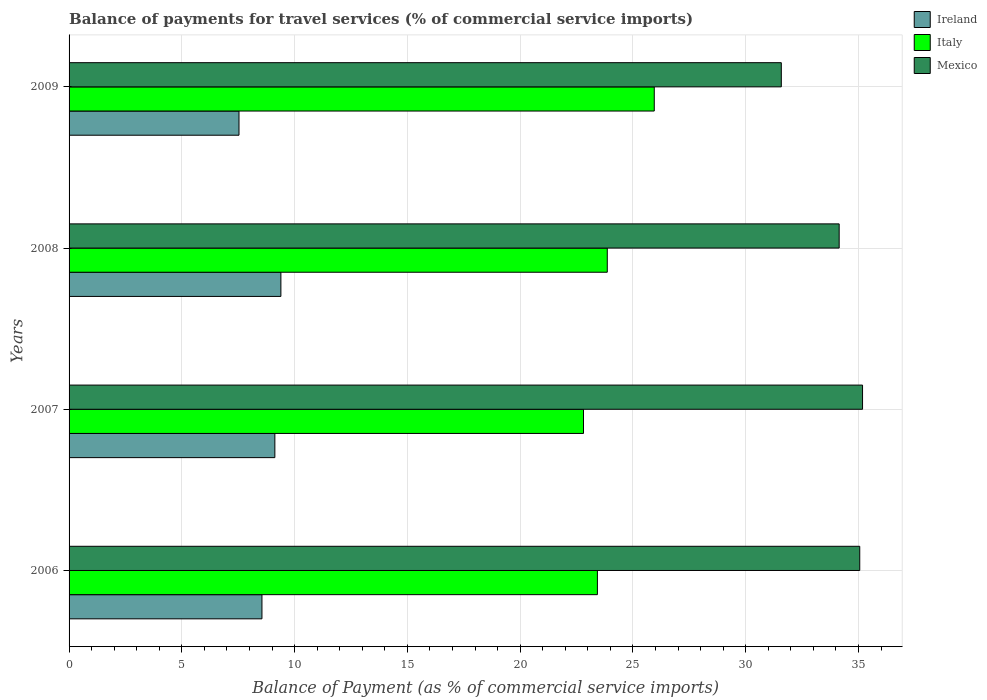How many different coloured bars are there?
Make the answer very short. 3. How many groups of bars are there?
Offer a very short reply. 4. How many bars are there on the 4th tick from the top?
Provide a succinct answer. 3. How many bars are there on the 4th tick from the bottom?
Provide a succinct answer. 3. What is the label of the 3rd group of bars from the top?
Offer a terse response. 2007. What is the balance of payments for travel services in Ireland in 2006?
Your response must be concise. 8.55. Across all years, what is the maximum balance of payments for travel services in Italy?
Make the answer very short. 25.95. Across all years, what is the minimum balance of payments for travel services in Ireland?
Offer a terse response. 7.53. In which year was the balance of payments for travel services in Italy maximum?
Offer a terse response. 2009. What is the total balance of payments for travel services in Ireland in the graph?
Your answer should be very brief. 34.6. What is the difference between the balance of payments for travel services in Ireland in 2006 and that in 2008?
Your response must be concise. -0.84. What is the difference between the balance of payments for travel services in Italy in 2006 and the balance of payments for travel services in Ireland in 2009?
Keep it short and to the point. 15.89. What is the average balance of payments for travel services in Mexico per year?
Offer a very short reply. 33.99. In the year 2009, what is the difference between the balance of payments for travel services in Italy and balance of payments for travel services in Ireland?
Your answer should be very brief. 18.41. What is the ratio of the balance of payments for travel services in Mexico in 2006 to that in 2007?
Ensure brevity in your answer.  1. What is the difference between the highest and the second highest balance of payments for travel services in Ireland?
Provide a short and direct response. 0.27. What is the difference between the highest and the lowest balance of payments for travel services in Italy?
Your answer should be very brief. 3.14. Is the sum of the balance of payments for travel services in Mexico in 2006 and 2009 greater than the maximum balance of payments for travel services in Italy across all years?
Your answer should be very brief. Yes. What does the 1st bar from the bottom in 2009 represents?
Your response must be concise. Ireland. Is it the case that in every year, the sum of the balance of payments for travel services in Italy and balance of payments for travel services in Ireland is greater than the balance of payments for travel services in Mexico?
Provide a succinct answer. No. Are all the bars in the graph horizontal?
Provide a succinct answer. Yes. Does the graph contain grids?
Your answer should be compact. Yes. Where does the legend appear in the graph?
Keep it short and to the point. Top right. How many legend labels are there?
Your response must be concise. 3. What is the title of the graph?
Provide a succinct answer. Balance of payments for travel services (% of commercial service imports). Does "Europe(all income levels)" appear as one of the legend labels in the graph?
Provide a short and direct response. No. What is the label or title of the X-axis?
Ensure brevity in your answer.  Balance of Payment (as % of commercial service imports). What is the label or title of the Y-axis?
Your answer should be very brief. Years. What is the Balance of Payment (as % of commercial service imports) in Ireland in 2006?
Offer a very short reply. 8.55. What is the Balance of Payment (as % of commercial service imports) in Italy in 2006?
Make the answer very short. 23.43. What is the Balance of Payment (as % of commercial service imports) in Mexico in 2006?
Make the answer very short. 35.06. What is the Balance of Payment (as % of commercial service imports) in Ireland in 2007?
Your answer should be very brief. 9.12. What is the Balance of Payment (as % of commercial service imports) in Italy in 2007?
Your response must be concise. 22.81. What is the Balance of Payment (as % of commercial service imports) in Mexico in 2007?
Make the answer very short. 35.18. What is the Balance of Payment (as % of commercial service imports) in Ireland in 2008?
Provide a succinct answer. 9.39. What is the Balance of Payment (as % of commercial service imports) of Italy in 2008?
Make the answer very short. 23.86. What is the Balance of Payment (as % of commercial service imports) of Mexico in 2008?
Keep it short and to the point. 34.14. What is the Balance of Payment (as % of commercial service imports) in Ireland in 2009?
Keep it short and to the point. 7.53. What is the Balance of Payment (as % of commercial service imports) of Italy in 2009?
Your answer should be very brief. 25.95. What is the Balance of Payment (as % of commercial service imports) of Mexico in 2009?
Your response must be concise. 31.58. Across all years, what is the maximum Balance of Payment (as % of commercial service imports) in Ireland?
Your response must be concise. 9.39. Across all years, what is the maximum Balance of Payment (as % of commercial service imports) in Italy?
Make the answer very short. 25.95. Across all years, what is the maximum Balance of Payment (as % of commercial service imports) of Mexico?
Provide a succinct answer. 35.18. Across all years, what is the minimum Balance of Payment (as % of commercial service imports) in Ireland?
Offer a terse response. 7.53. Across all years, what is the minimum Balance of Payment (as % of commercial service imports) in Italy?
Ensure brevity in your answer.  22.81. Across all years, what is the minimum Balance of Payment (as % of commercial service imports) of Mexico?
Ensure brevity in your answer.  31.58. What is the total Balance of Payment (as % of commercial service imports) in Ireland in the graph?
Offer a terse response. 34.6. What is the total Balance of Payment (as % of commercial service imports) of Italy in the graph?
Ensure brevity in your answer.  96.04. What is the total Balance of Payment (as % of commercial service imports) of Mexico in the graph?
Make the answer very short. 135.96. What is the difference between the Balance of Payment (as % of commercial service imports) of Ireland in 2006 and that in 2007?
Offer a terse response. -0.57. What is the difference between the Balance of Payment (as % of commercial service imports) of Italy in 2006 and that in 2007?
Offer a terse response. 0.62. What is the difference between the Balance of Payment (as % of commercial service imports) in Mexico in 2006 and that in 2007?
Your answer should be very brief. -0.12. What is the difference between the Balance of Payment (as % of commercial service imports) in Ireland in 2006 and that in 2008?
Provide a succinct answer. -0.84. What is the difference between the Balance of Payment (as % of commercial service imports) in Italy in 2006 and that in 2008?
Your answer should be very brief. -0.44. What is the difference between the Balance of Payment (as % of commercial service imports) of Mexico in 2006 and that in 2008?
Ensure brevity in your answer.  0.91. What is the difference between the Balance of Payment (as % of commercial service imports) of Ireland in 2006 and that in 2009?
Ensure brevity in your answer.  1.02. What is the difference between the Balance of Payment (as % of commercial service imports) of Italy in 2006 and that in 2009?
Offer a terse response. -2.52. What is the difference between the Balance of Payment (as % of commercial service imports) of Mexico in 2006 and that in 2009?
Make the answer very short. 3.48. What is the difference between the Balance of Payment (as % of commercial service imports) in Ireland in 2007 and that in 2008?
Provide a short and direct response. -0.27. What is the difference between the Balance of Payment (as % of commercial service imports) of Italy in 2007 and that in 2008?
Provide a short and direct response. -1.05. What is the difference between the Balance of Payment (as % of commercial service imports) of Mexico in 2007 and that in 2008?
Provide a short and direct response. 1.04. What is the difference between the Balance of Payment (as % of commercial service imports) of Ireland in 2007 and that in 2009?
Keep it short and to the point. 1.59. What is the difference between the Balance of Payment (as % of commercial service imports) in Italy in 2007 and that in 2009?
Make the answer very short. -3.14. What is the difference between the Balance of Payment (as % of commercial service imports) in Mexico in 2007 and that in 2009?
Offer a terse response. 3.6. What is the difference between the Balance of Payment (as % of commercial service imports) of Ireland in 2008 and that in 2009?
Provide a short and direct response. 1.86. What is the difference between the Balance of Payment (as % of commercial service imports) in Italy in 2008 and that in 2009?
Make the answer very short. -2.08. What is the difference between the Balance of Payment (as % of commercial service imports) of Mexico in 2008 and that in 2009?
Provide a short and direct response. 2.56. What is the difference between the Balance of Payment (as % of commercial service imports) of Ireland in 2006 and the Balance of Payment (as % of commercial service imports) of Italy in 2007?
Provide a succinct answer. -14.26. What is the difference between the Balance of Payment (as % of commercial service imports) of Ireland in 2006 and the Balance of Payment (as % of commercial service imports) of Mexico in 2007?
Keep it short and to the point. -26.63. What is the difference between the Balance of Payment (as % of commercial service imports) in Italy in 2006 and the Balance of Payment (as % of commercial service imports) in Mexico in 2007?
Give a very brief answer. -11.76. What is the difference between the Balance of Payment (as % of commercial service imports) of Ireland in 2006 and the Balance of Payment (as % of commercial service imports) of Italy in 2008?
Your answer should be compact. -15.31. What is the difference between the Balance of Payment (as % of commercial service imports) in Ireland in 2006 and the Balance of Payment (as % of commercial service imports) in Mexico in 2008?
Provide a succinct answer. -25.59. What is the difference between the Balance of Payment (as % of commercial service imports) in Italy in 2006 and the Balance of Payment (as % of commercial service imports) in Mexico in 2008?
Make the answer very short. -10.72. What is the difference between the Balance of Payment (as % of commercial service imports) of Ireland in 2006 and the Balance of Payment (as % of commercial service imports) of Italy in 2009?
Give a very brief answer. -17.39. What is the difference between the Balance of Payment (as % of commercial service imports) in Ireland in 2006 and the Balance of Payment (as % of commercial service imports) in Mexico in 2009?
Provide a short and direct response. -23.03. What is the difference between the Balance of Payment (as % of commercial service imports) in Italy in 2006 and the Balance of Payment (as % of commercial service imports) in Mexico in 2009?
Give a very brief answer. -8.15. What is the difference between the Balance of Payment (as % of commercial service imports) in Ireland in 2007 and the Balance of Payment (as % of commercial service imports) in Italy in 2008?
Make the answer very short. -14.74. What is the difference between the Balance of Payment (as % of commercial service imports) in Ireland in 2007 and the Balance of Payment (as % of commercial service imports) in Mexico in 2008?
Your answer should be compact. -25.02. What is the difference between the Balance of Payment (as % of commercial service imports) of Italy in 2007 and the Balance of Payment (as % of commercial service imports) of Mexico in 2008?
Your response must be concise. -11.34. What is the difference between the Balance of Payment (as % of commercial service imports) in Ireland in 2007 and the Balance of Payment (as % of commercial service imports) in Italy in 2009?
Give a very brief answer. -16.82. What is the difference between the Balance of Payment (as % of commercial service imports) of Ireland in 2007 and the Balance of Payment (as % of commercial service imports) of Mexico in 2009?
Provide a short and direct response. -22.46. What is the difference between the Balance of Payment (as % of commercial service imports) in Italy in 2007 and the Balance of Payment (as % of commercial service imports) in Mexico in 2009?
Provide a short and direct response. -8.77. What is the difference between the Balance of Payment (as % of commercial service imports) in Ireland in 2008 and the Balance of Payment (as % of commercial service imports) in Italy in 2009?
Provide a short and direct response. -16.55. What is the difference between the Balance of Payment (as % of commercial service imports) of Ireland in 2008 and the Balance of Payment (as % of commercial service imports) of Mexico in 2009?
Your answer should be very brief. -22.19. What is the difference between the Balance of Payment (as % of commercial service imports) of Italy in 2008 and the Balance of Payment (as % of commercial service imports) of Mexico in 2009?
Your answer should be compact. -7.72. What is the average Balance of Payment (as % of commercial service imports) of Ireland per year?
Make the answer very short. 8.65. What is the average Balance of Payment (as % of commercial service imports) of Italy per year?
Your response must be concise. 24.01. What is the average Balance of Payment (as % of commercial service imports) in Mexico per year?
Make the answer very short. 33.99. In the year 2006, what is the difference between the Balance of Payment (as % of commercial service imports) of Ireland and Balance of Payment (as % of commercial service imports) of Italy?
Ensure brevity in your answer.  -14.87. In the year 2006, what is the difference between the Balance of Payment (as % of commercial service imports) of Ireland and Balance of Payment (as % of commercial service imports) of Mexico?
Provide a short and direct response. -26.51. In the year 2006, what is the difference between the Balance of Payment (as % of commercial service imports) of Italy and Balance of Payment (as % of commercial service imports) of Mexico?
Your answer should be very brief. -11.63. In the year 2007, what is the difference between the Balance of Payment (as % of commercial service imports) of Ireland and Balance of Payment (as % of commercial service imports) of Italy?
Provide a short and direct response. -13.68. In the year 2007, what is the difference between the Balance of Payment (as % of commercial service imports) of Ireland and Balance of Payment (as % of commercial service imports) of Mexico?
Your response must be concise. -26.06. In the year 2007, what is the difference between the Balance of Payment (as % of commercial service imports) of Italy and Balance of Payment (as % of commercial service imports) of Mexico?
Make the answer very short. -12.37. In the year 2008, what is the difference between the Balance of Payment (as % of commercial service imports) in Ireland and Balance of Payment (as % of commercial service imports) in Italy?
Your answer should be compact. -14.47. In the year 2008, what is the difference between the Balance of Payment (as % of commercial service imports) in Ireland and Balance of Payment (as % of commercial service imports) in Mexico?
Keep it short and to the point. -24.75. In the year 2008, what is the difference between the Balance of Payment (as % of commercial service imports) of Italy and Balance of Payment (as % of commercial service imports) of Mexico?
Your answer should be very brief. -10.28. In the year 2009, what is the difference between the Balance of Payment (as % of commercial service imports) of Ireland and Balance of Payment (as % of commercial service imports) of Italy?
Provide a succinct answer. -18.41. In the year 2009, what is the difference between the Balance of Payment (as % of commercial service imports) of Ireland and Balance of Payment (as % of commercial service imports) of Mexico?
Give a very brief answer. -24.05. In the year 2009, what is the difference between the Balance of Payment (as % of commercial service imports) of Italy and Balance of Payment (as % of commercial service imports) of Mexico?
Offer a terse response. -5.63. What is the ratio of the Balance of Payment (as % of commercial service imports) of Ireland in 2006 to that in 2007?
Give a very brief answer. 0.94. What is the ratio of the Balance of Payment (as % of commercial service imports) in Italy in 2006 to that in 2007?
Offer a terse response. 1.03. What is the ratio of the Balance of Payment (as % of commercial service imports) of Ireland in 2006 to that in 2008?
Your answer should be compact. 0.91. What is the ratio of the Balance of Payment (as % of commercial service imports) in Italy in 2006 to that in 2008?
Ensure brevity in your answer.  0.98. What is the ratio of the Balance of Payment (as % of commercial service imports) of Mexico in 2006 to that in 2008?
Provide a succinct answer. 1.03. What is the ratio of the Balance of Payment (as % of commercial service imports) in Ireland in 2006 to that in 2009?
Offer a very short reply. 1.14. What is the ratio of the Balance of Payment (as % of commercial service imports) of Italy in 2006 to that in 2009?
Make the answer very short. 0.9. What is the ratio of the Balance of Payment (as % of commercial service imports) of Mexico in 2006 to that in 2009?
Your answer should be compact. 1.11. What is the ratio of the Balance of Payment (as % of commercial service imports) of Ireland in 2007 to that in 2008?
Give a very brief answer. 0.97. What is the ratio of the Balance of Payment (as % of commercial service imports) of Italy in 2007 to that in 2008?
Offer a very short reply. 0.96. What is the ratio of the Balance of Payment (as % of commercial service imports) of Mexico in 2007 to that in 2008?
Provide a succinct answer. 1.03. What is the ratio of the Balance of Payment (as % of commercial service imports) of Ireland in 2007 to that in 2009?
Make the answer very short. 1.21. What is the ratio of the Balance of Payment (as % of commercial service imports) in Italy in 2007 to that in 2009?
Provide a short and direct response. 0.88. What is the ratio of the Balance of Payment (as % of commercial service imports) in Mexico in 2007 to that in 2009?
Offer a terse response. 1.11. What is the ratio of the Balance of Payment (as % of commercial service imports) of Ireland in 2008 to that in 2009?
Offer a terse response. 1.25. What is the ratio of the Balance of Payment (as % of commercial service imports) of Italy in 2008 to that in 2009?
Ensure brevity in your answer.  0.92. What is the ratio of the Balance of Payment (as % of commercial service imports) in Mexico in 2008 to that in 2009?
Your answer should be very brief. 1.08. What is the difference between the highest and the second highest Balance of Payment (as % of commercial service imports) of Ireland?
Provide a succinct answer. 0.27. What is the difference between the highest and the second highest Balance of Payment (as % of commercial service imports) of Italy?
Provide a short and direct response. 2.08. What is the difference between the highest and the second highest Balance of Payment (as % of commercial service imports) in Mexico?
Give a very brief answer. 0.12. What is the difference between the highest and the lowest Balance of Payment (as % of commercial service imports) in Ireland?
Offer a terse response. 1.86. What is the difference between the highest and the lowest Balance of Payment (as % of commercial service imports) in Italy?
Provide a succinct answer. 3.14. What is the difference between the highest and the lowest Balance of Payment (as % of commercial service imports) in Mexico?
Ensure brevity in your answer.  3.6. 